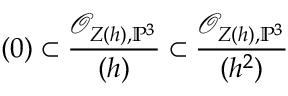<formula> <loc_0><loc_0><loc_500><loc_500>( 0 ) \subset { \frac { { \mathcal { O } } _ { Z ( h ) , \mathbb { P } ^ { 3 } } } { ( h ) } } \subset { \frac { { \mathcal { O } } _ { Z ( h ) , \mathbb { P } ^ { 3 } } } { ( h ^ { 2 } ) } }</formula> 